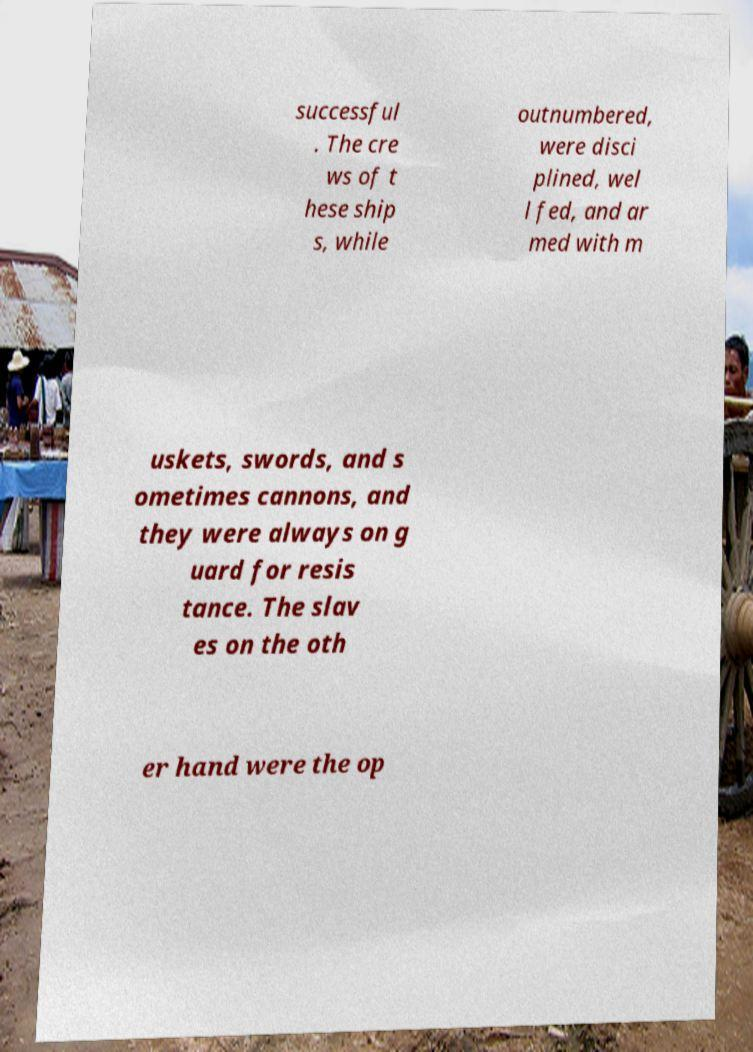There's text embedded in this image that I need extracted. Can you transcribe it verbatim? successful . The cre ws of t hese ship s, while outnumbered, were disci plined, wel l fed, and ar med with m uskets, swords, and s ometimes cannons, and they were always on g uard for resis tance. The slav es on the oth er hand were the op 